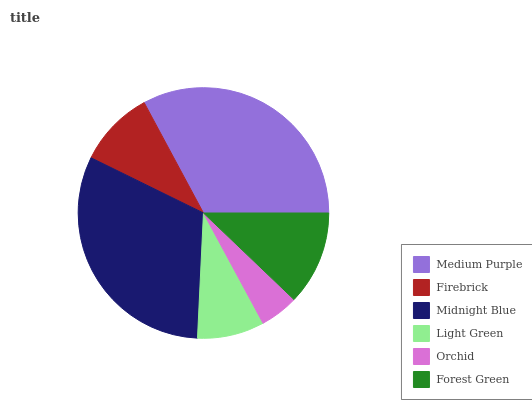Is Orchid the minimum?
Answer yes or no. Yes. Is Medium Purple the maximum?
Answer yes or no. Yes. Is Firebrick the minimum?
Answer yes or no. No. Is Firebrick the maximum?
Answer yes or no. No. Is Medium Purple greater than Firebrick?
Answer yes or no. Yes. Is Firebrick less than Medium Purple?
Answer yes or no. Yes. Is Firebrick greater than Medium Purple?
Answer yes or no. No. Is Medium Purple less than Firebrick?
Answer yes or no. No. Is Forest Green the high median?
Answer yes or no. Yes. Is Firebrick the low median?
Answer yes or no. Yes. Is Midnight Blue the high median?
Answer yes or no. No. Is Orchid the low median?
Answer yes or no. No. 